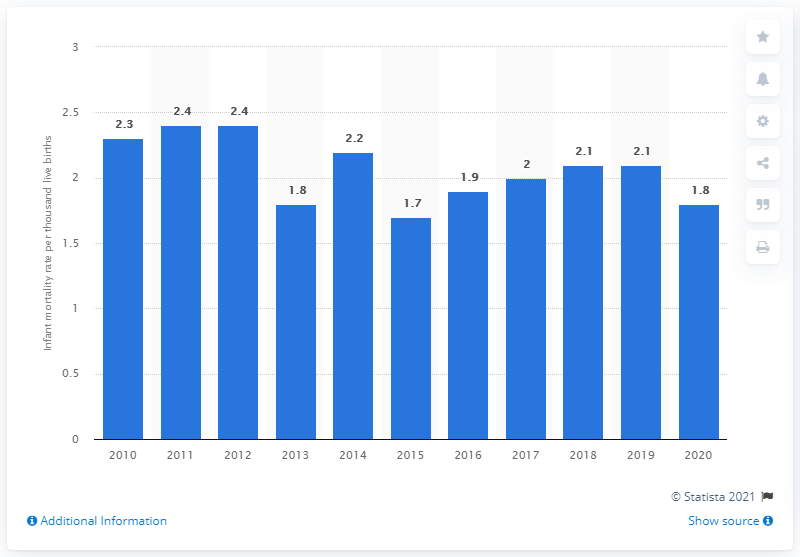List a handful of essential elements in this visual. In 2015, the infant mortality rate in Finland was 1.7 deaths per thousand live births. In 2020, Finland's infant mortality rate per thousand live births was 1.8. 